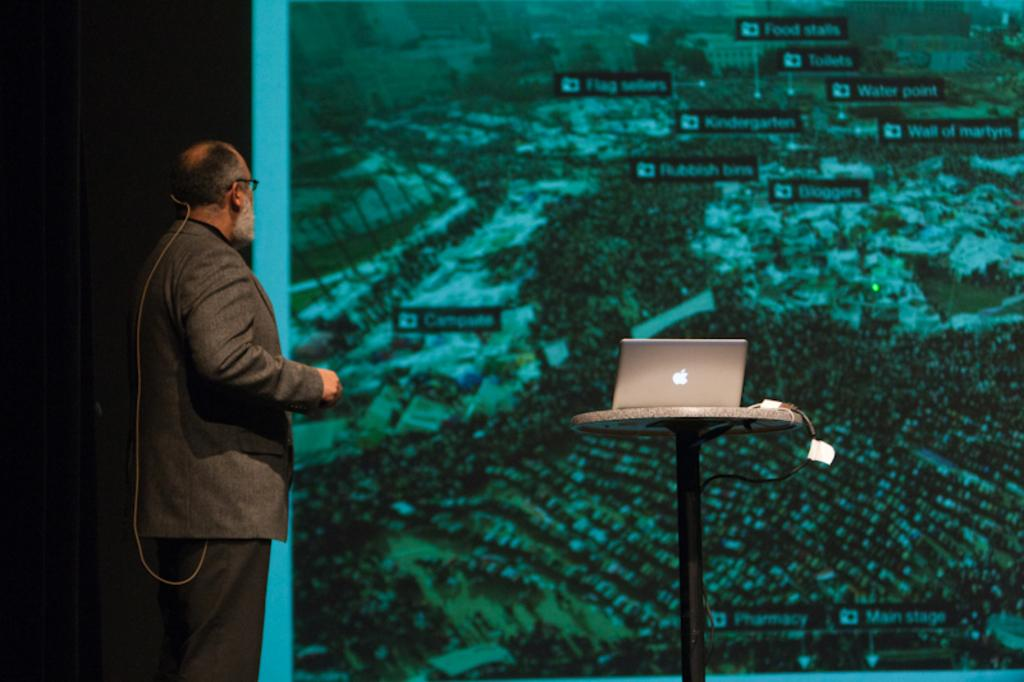Who is present in the image? There is a man in the image. What is the man wearing? The man is wearing a suit. What object can be seen on a table in the image? There is a laptop on a table in the image. What can be seen in the background of the image? There is a screen visible in the background of the image. What type of snow can be seen falling outside the window in the image? There is no window or snow visible in the image. What business offer is the man making to the person on the other side of the screen? There is no indication of a business offer or a person on the other side of the screen in the image. 